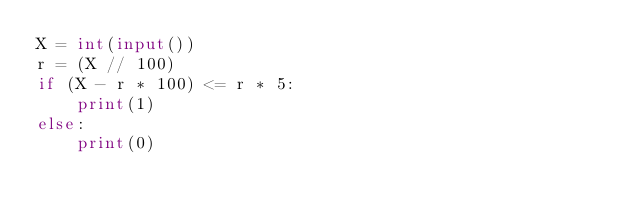<code> <loc_0><loc_0><loc_500><loc_500><_Python_>X = int(input())
r = (X // 100)
if (X - r * 100) <= r * 5:
    print(1)
else:
    print(0)</code> 